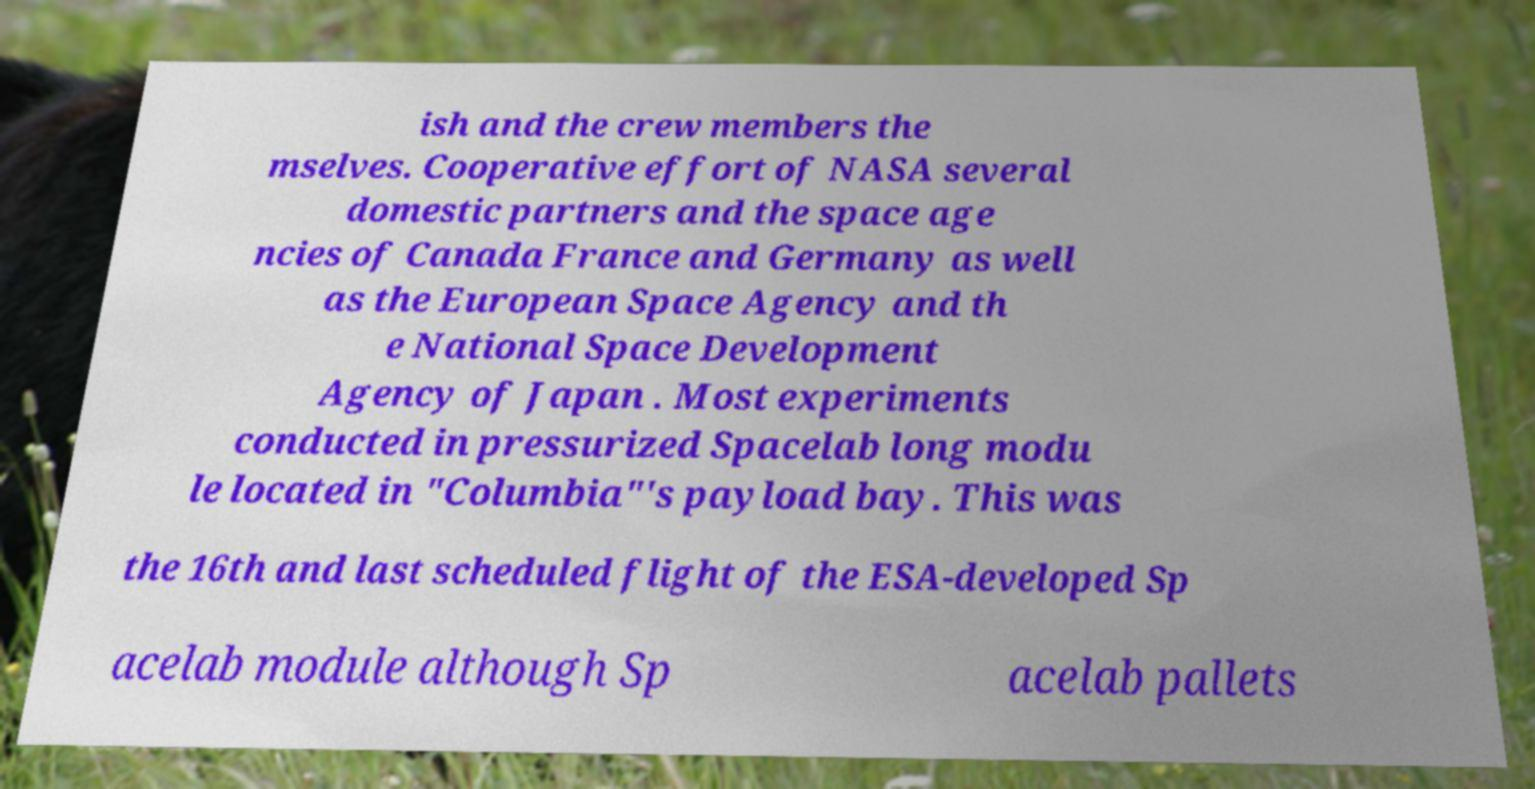I need the written content from this picture converted into text. Can you do that? ish and the crew members the mselves. Cooperative effort of NASA several domestic partners and the space age ncies of Canada France and Germany as well as the European Space Agency and th e National Space Development Agency of Japan . Most experiments conducted in pressurized Spacelab long modu le located in "Columbia"'s payload bay. This was the 16th and last scheduled flight of the ESA-developed Sp acelab module although Sp acelab pallets 